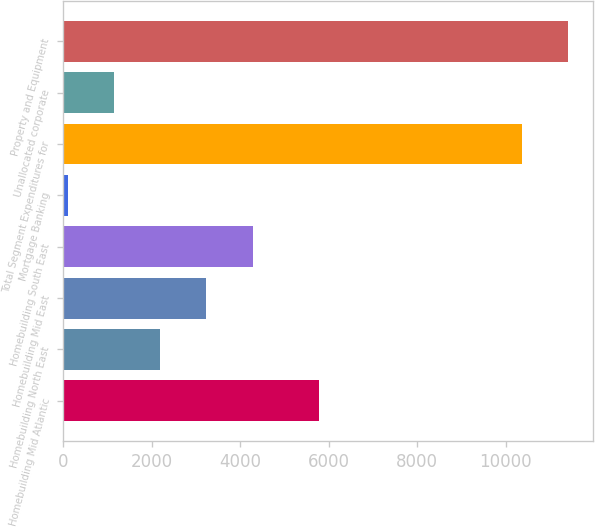<chart> <loc_0><loc_0><loc_500><loc_500><bar_chart><fcel>Homebuilding Mid Atlantic<fcel>Homebuilding North East<fcel>Homebuilding Mid East<fcel>Homebuilding South East<fcel>Mortgage Banking<fcel>Total Segment Expenditures for<fcel>Unallocated corporate<fcel>Property and Equipment<nl><fcel>5785<fcel>2185.8<fcel>3230.7<fcel>4275.6<fcel>96<fcel>10360<fcel>1140.9<fcel>11404.9<nl></chart> 